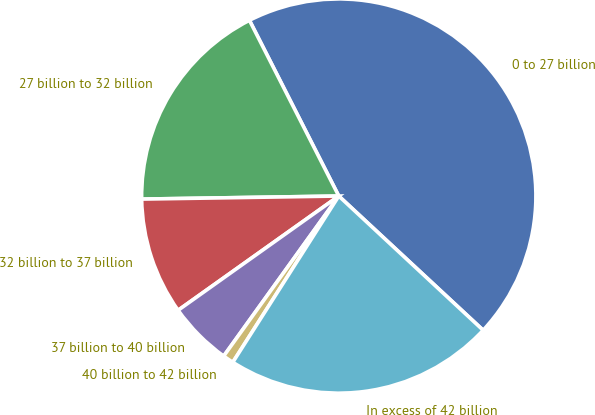Convert chart. <chart><loc_0><loc_0><loc_500><loc_500><pie_chart><fcel>0 to 27 billion<fcel>27 billion to 32 billion<fcel>32 billion to 37 billion<fcel>37 billion to 40 billion<fcel>40 billion to 42 billion<fcel>In excess of 42 billion<nl><fcel>44.4%<fcel>17.76%<fcel>9.59%<fcel>5.24%<fcel>0.89%<fcel>22.11%<nl></chart> 